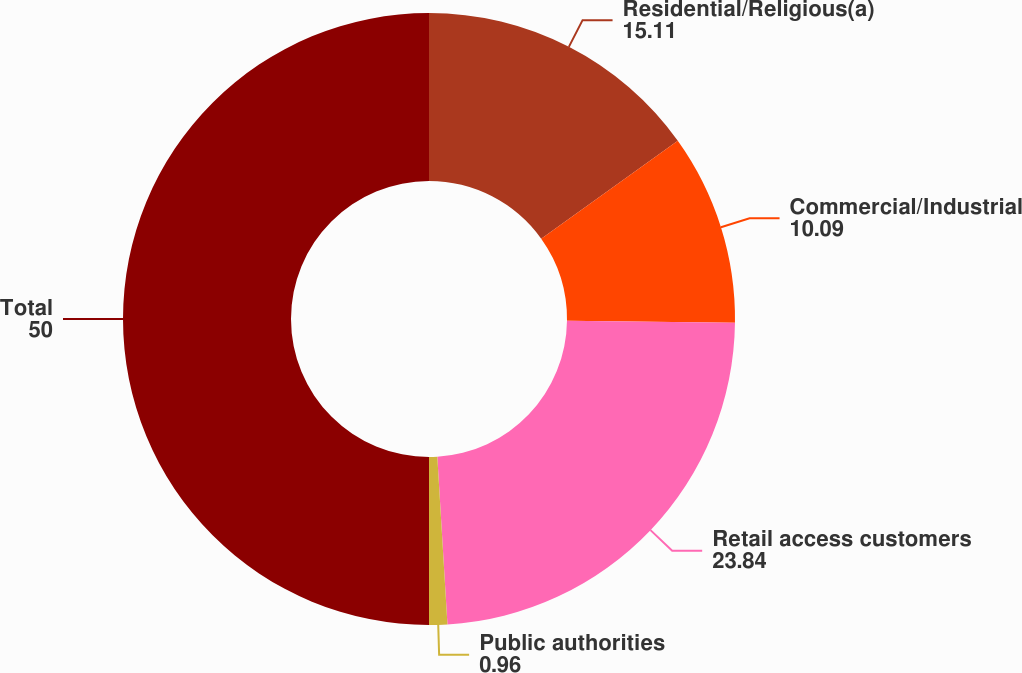Convert chart to OTSL. <chart><loc_0><loc_0><loc_500><loc_500><pie_chart><fcel>Residential/Religious(a)<fcel>Commercial/Industrial<fcel>Retail access customers<fcel>Public authorities<fcel>Total<nl><fcel>15.11%<fcel>10.09%<fcel>23.84%<fcel>0.96%<fcel>50.0%<nl></chart> 